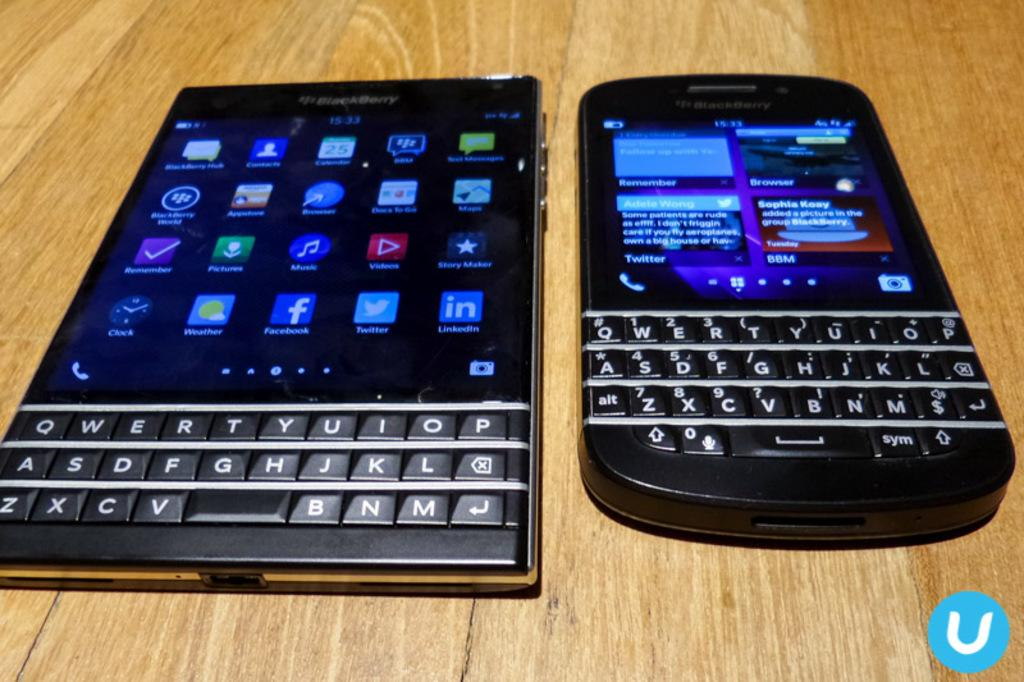<image>
Render a clear and concise summary of the photo. The clock on the larger Blackberry phone is showing 15:33 